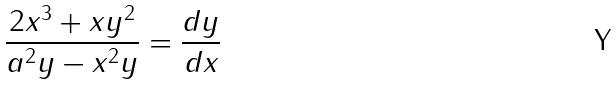<formula> <loc_0><loc_0><loc_500><loc_500>\frac { 2 x ^ { 3 } + x y ^ { 2 } } { a ^ { 2 } y - x ^ { 2 } y } = \frac { d y } { d x }</formula> 